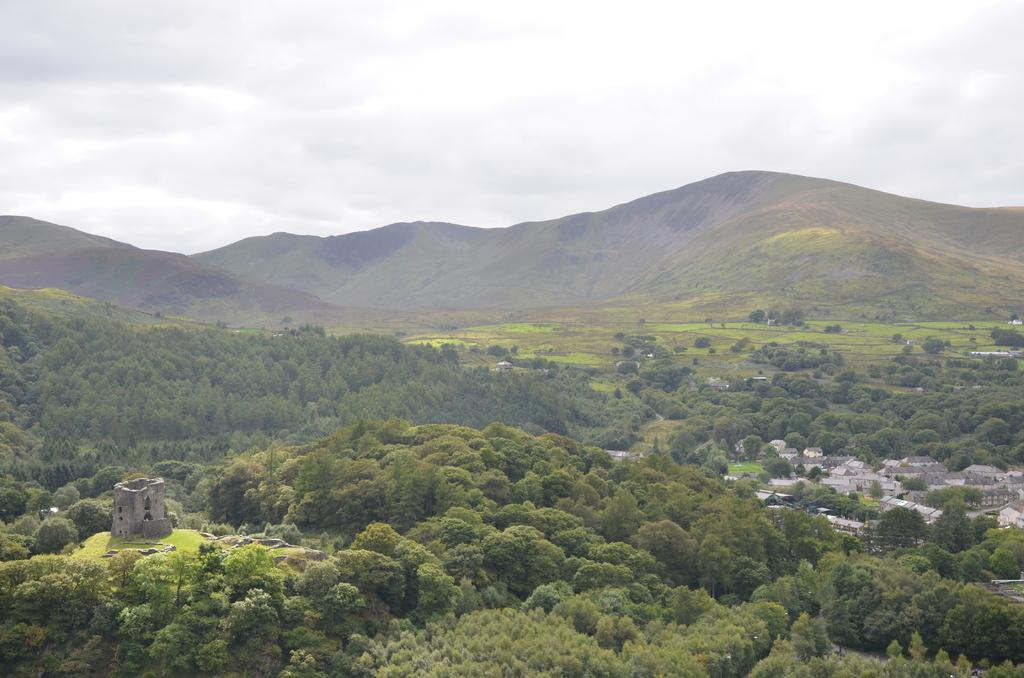What type of natural elements can be seen in the image? There are trees and plants in the image. What type of man-made structures are present in the image? There are historical constructions in the image. What is the ground surface like in the image? The grass surface is visible in the image. What can be seen in the background of the image? There are trees, hills, and the sky in the background of the image. What is the condition of the sky in the image? Clouds are present in the sky. What type of advice does the minister give to the uncle in the image? There is no minister or uncle present in the image; it features trees, plants, historical constructions, grass, hills, and the sky. What type of decorative object is placed on the table in the image? There is no table or vase present in the image. 